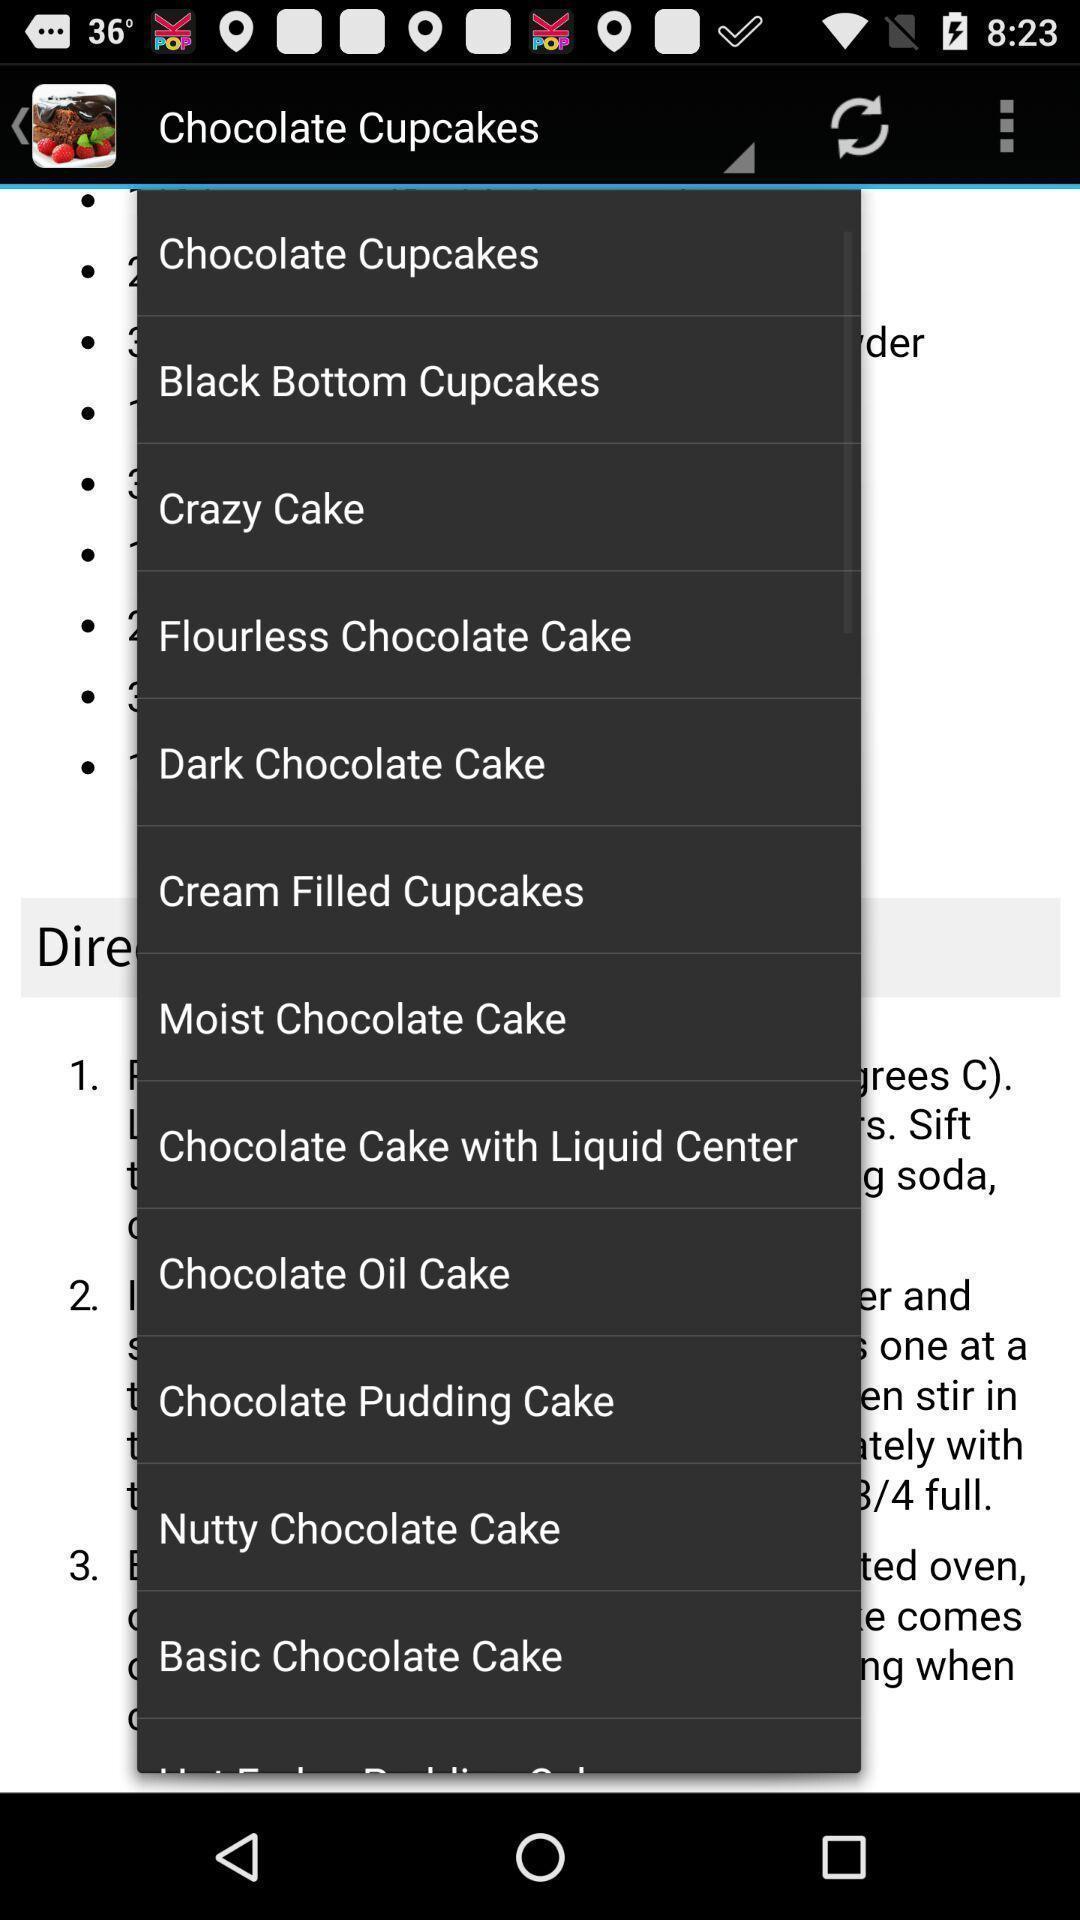Describe this image in words. Pop-up showing list of various chocolate cup cakes. 